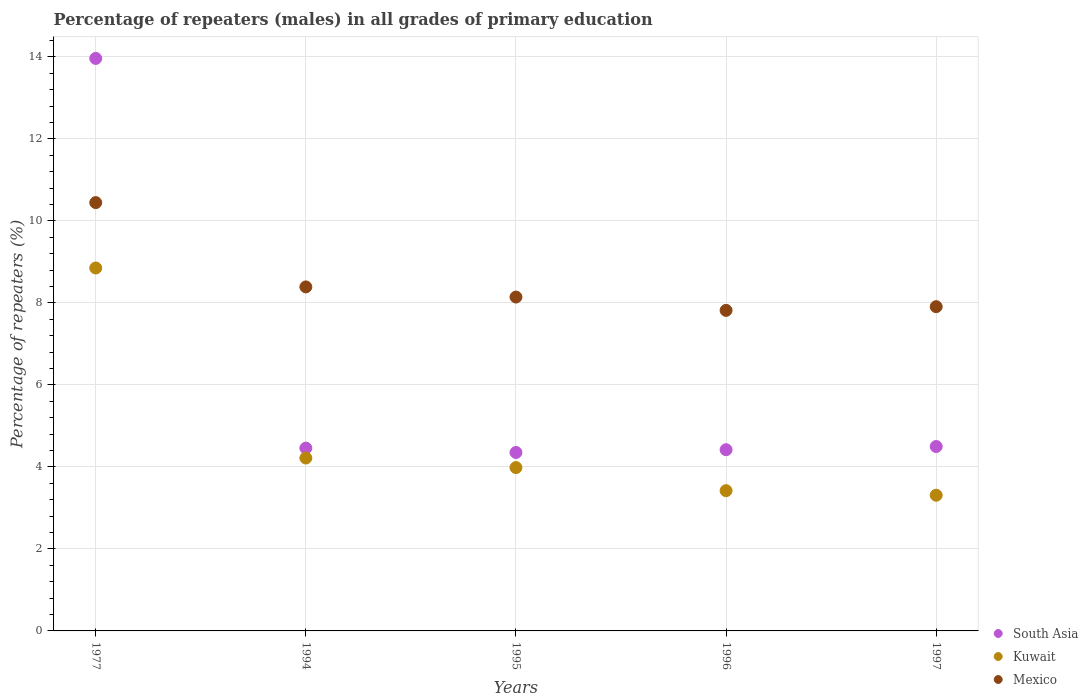What is the percentage of repeaters (males) in Kuwait in 1977?
Provide a succinct answer. 8.85. Across all years, what is the maximum percentage of repeaters (males) in South Asia?
Your answer should be compact. 13.96. Across all years, what is the minimum percentage of repeaters (males) in Mexico?
Keep it short and to the point. 7.82. In which year was the percentage of repeaters (males) in Kuwait maximum?
Provide a short and direct response. 1977. What is the total percentage of repeaters (males) in Mexico in the graph?
Ensure brevity in your answer.  42.71. What is the difference between the percentage of repeaters (males) in South Asia in 1996 and that in 1997?
Provide a short and direct response. -0.08. What is the difference between the percentage of repeaters (males) in South Asia in 1994 and the percentage of repeaters (males) in Kuwait in 1997?
Provide a short and direct response. 1.15. What is the average percentage of repeaters (males) in Mexico per year?
Your answer should be very brief. 8.54. In the year 1996, what is the difference between the percentage of repeaters (males) in Kuwait and percentage of repeaters (males) in South Asia?
Provide a short and direct response. -1. In how many years, is the percentage of repeaters (males) in Kuwait greater than 13.6 %?
Offer a very short reply. 0. What is the ratio of the percentage of repeaters (males) in Kuwait in 1996 to that in 1997?
Make the answer very short. 1.03. Is the difference between the percentage of repeaters (males) in Kuwait in 1977 and 1994 greater than the difference between the percentage of repeaters (males) in South Asia in 1977 and 1994?
Keep it short and to the point. No. What is the difference between the highest and the second highest percentage of repeaters (males) in Kuwait?
Provide a short and direct response. 4.63. What is the difference between the highest and the lowest percentage of repeaters (males) in South Asia?
Your answer should be very brief. 9.61. Is the sum of the percentage of repeaters (males) in South Asia in 1995 and 1997 greater than the maximum percentage of repeaters (males) in Mexico across all years?
Give a very brief answer. No. Does the percentage of repeaters (males) in South Asia monotonically increase over the years?
Keep it short and to the point. No. Is the percentage of repeaters (males) in South Asia strictly less than the percentage of repeaters (males) in Kuwait over the years?
Provide a succinct answer. No. How many years are there in the graph?
Ensure brevity in your answer.  5. Does the graph contain grids?
Provide a short and direct response. Yes. How are the legend labels stacked?
Provide a succinct answer. Vertical. What is the title of the graph?
Offer a very short reply. Percentage of repeaters (males) in all grades of primary education. Does "Vietnam" appear as one of the legend labels in the graph?
Provide a succinct answer. No. What is the label or title of the Y-axis?
Your answer should be compact. Percentage of repeaters (%). What is the Percentage of repeaters (%) of South Asia in 1977?
Offer a very short reply. 13.96. What is the Percentage of repeaters (%) of Kuwait in 1977?
Your answer should be very brief. 8.85. What is the Percentage of repeaters (%) of Mexico in 1977?
Your answer should be very brief. 10.45. What is the Percentage of repeaters (%) in South Asia in 1994?
Your answer should be compact. 4.46. What is the Percentage of repeaters (%) in Kuwait in 1994?
Provide a short and direct response. 4.22. What is the Percentage of repeaters (%) of Mexico in 1994?
Make the answer very short. 8.39. What is the Percentage of repeaters (%) in South Asia in 1995?
Provide a short and direct response. 4.35. What is the Percentage of repeaters (%) of Kuwait in 1995?
Your answer should be compact. 3.98. What is the Percentage of repeaters (%) in Mexico in 1995?
Your answer should be very brief. 8.14. What is the Percentage of repeaters (%) in South Asia in 1996?
Provide a succinct answer. 4.42. What is the Percentage of repeaters (%) of Kuwait in 1996?
Provide a short and direct response. 3.42. What is the Percentage of repeaters (%) of Mexico in 1996?
Provide a short and direct response. 7.82. What is the Percentage of repeaters (%) of South Asia in 1997?
Ensure brevity in your answer.  4.5. What is the Percentage of repeaters (%) of Kuwait in 1997?
Provide a short and direct response. 3.31. What is the Percentage of repeaters (%) of Mexico in 1997?
Offer a terse response. 7.91. Across all years, what is the maximum Percentage of repeaters (%) of South Asia?
Provide a short and direct response. 13.96. Across all years, what is the maximum Percentage of repeaters (%) in Kuwait?
Offer a terse response. 8.85. Across all years, what is the maximum Percentage of repeaters (%) of Mexico?
Offer a very short reply. 10.45. Across all years, what is the minimum Percentage of repeaters (%) in South Asia?
Give a very brief answer. 4.35. Across all years, what is the minimum Percentage of repeaters (%) in Kuwait?
Make the answer very short. 3.31. Across all years, what is the minimum Percentage of repeaters (%) in Mexico?
Make the answer very short. 7.82. What is the total Percentage of repeaters (%) in South Asia in the graph?
Make the answer very short. 31.69. What is the total Percentage of repeaters (%) of Kuwait in the graph?
Make the answer very short. 23.78. What is the total Percentage of repeaters (%) in Mexico in the graph?
Keep it short and to the point. 42.71. What is the difference between the Percentage of repeaters (%) in South Asia in 1977 and that in 1994?
Keep it short and to the point. 9.5. What is the difference between the Percentage of repeaters (%) in Kuwait in 1977 and that in 1994?
Ensure brevity in your answer.  4.63. What is the difference between the Percentage of repeaters (%) of Mexico in 1977 and that in 1994?
Provide a short and direct response. 2.06. What is the difference between the Percentage of repeaters (%) of South Asia in 1977 and that in 1995?
Your answer should be very brief. 9.61. What is the difference between the Percentage of repeaters (%) of Kuwait in 1977 and that in 1995?
Your response must be concise. 4.87. What is the difference between the Percentage of repeaters (%) of Mexico in 1977 and that in 1995?
Keep it short and to the point. 2.3. What is the difference between the Percentage of repeaters (%) of South Asia in 1977 and that in 1996?
Keep it short and to the point. 9.54. What is the difference between the Percentage of repeaters (%) of Kuwait in 1977 and that in 1996?
Offer a very short reply. 5.43. What is the difference between the Percentage of repeaters (%) in Mexico in 1977 and that in 1996?
Make the answer very short. 2.63. What is the difference between the Percentage of repeaters (%) in South Asia in 1977 and that in 1997?
Provide a short and direct response. 9.47. What is the difference between the Percentage of repeaters (%) of Kuwait in 1977 and that in 1997?
Your answer should be compact. 5.54. What is the difference between the Percentage of repeaters (%) in Mexico in 1977 and that in 1997?
Ensure brevity in your answer.  2.54. What is the difference between the Percentage of repeaters (%) in South Asia in 1994 and that in 1995?
Offer a terse response. 0.11. What is the difference between the Percentage of repeaters (%) in Kuwait in 1994 and that in 1995?
Offer a very short reply. 0.23. What is the difference between the Percentage of repeaters (%) in Mexico in 1994 and that in 1995?
Ensure brevity in your answer.  0.25. What is the difference between the Percentage of repeaters (%) of South Asia in 1994 and that in 1996?
Make the answer very short. 0.04. What is the difference between the Percentage of repeaters (%) in Kuwait in 1994 and that in 1996?
Your answer should be compact. 0.8. What is the difference between the Percentage of repeaters (%) in Mexico in 1994 and that in 1996?
Offer a very short reply. 0.57. What is the difference between the Percentage of repeaters (%) in South Asia in 1994 and that in 1997?
Ensure brevity in your answer.  -0.04. What is the difference between the Percentage of repeaters (%) in Kuwait in 1994 and that in 1997?
Ensure brevity in your answer.  0.91. What is the difference between the Percentage of repeaters (%) in Mexico in 1994 and that in 1997?
Make the answer very short. 0.48. What is the difference between the Percentage of repeaters (%) of South Asia in 1995 and that in 1996?
Make the answer very short. -0.07. What is the difference between the Percentage of repeaters (%) of Kuwait in 1995 and that in 1996?
Your answer should be compact. 0.56. What is the difference between the Percentage of repeaters (%) of Mexico in 1995 and that in 1996?
Your answer should be very brief. 0.33. What is the difference between the Percentage of repeaters (%) of South Asia in 1995 and that in 1997?
Provide a short and direct response. -0.14. What is the difference between the Percentage of repeaters (%) of Kuwait in 1995 and that in 1997?
Keep it short and to the point. 0.67. What is the difference between the Percentage of repeaters (%) of Mexico in 1995 and that in 1997?
Provide a short and direct response. 0.23. What is the difference between the Percentage of repeaters (%) in South Asia in 1996 and that in 1997?
Provide a short and direct response. -0.08. What is the difference between the Percentage of repeaters (%) of Kuwait in 1996 and that in 1997?
Provide a succinct answer. 0.11. What is the difference between the Percentage of repeaters (%) of Mexico in 1996 and that in 1997?
Provide a succinct answer. -0.09. What is the difference between the Percentage of repeaters (%) in South Asia in 1977 and the Percentage of repeaters (%) in Kuwait in 1994?
Your response must be concise. 9.75. What is the difference between the Percentage of repeaters (%) of South Asia in 1977 and the Percentage of repeaters (%) of Mexico in 1994?
Offer a terse response. 5.57. What is the difference between the Percentage of repeaters (%) in Kuwait in 1977 and the Percentage of repeaters (%) in Mexico in 1994?
Provide a short and direct response. 0.46. What is the difference between the Percentage of repeaters (%) in South Asia in 1977 and the Percentage of repeaters (%) in Kuwait in 1995?
Provide a succinct answer. 9.98. What is the difference between the Percentage of repeaters (%) in South Asia in 1977 and the Percentage of repeaters (%) in Mexico in 1995?
Offer a terse response. 5.82. What is the difference between the Percentage of repeaters (%) of Kuwait in 1977 and the Percentage of repeaters (%) of Mexico in 1995?
Offer a terse response. 0.71. What is the difference between the Percentage of repeaters (%) in South Asia in 1977 and the Percentage of repeaters (%) in Kuwait in 1996?
Your answer should be compact. 10.54. What is the difference between the Percentage of repeaters (%) in South Asia in 1977 and the Percentage of repeaters (%) in Mexico in 1996?
Provide a succinct answer. 6.15. What is the difference between the Percentage of repeaters (%) in Kuwait in 1977 and the Percentage of repeaters (%) in Mexico in 1996?
Your response must be concise. 1.03. What is the difference between the Percentage of repeaters (%) of South Asia in 1977 and the Percentage of repeaters (%) of Kuwait in 1997?
Provide a succinct answer. 10.65. What is the difference between the Percentage of repeaters (%) of South Asia in 1977 and the Percentage of repeaters (%) of Mexico in 1997?
Ensure brevity in your answer.  6.05. What is the difference between the Percentage of repeaters (%) in Kuwait in 1977 and the Percentage of repeaters (%) in Mexico in 1997?
Offer a very short reply. 0.94. What is the difference between the Percentage of repeaters (%) in South Asia in 1994 and the Percentage of repeaters (%) in Kuwait in 1995?
Keep it short and to the point. 0.48. What is the difference between the Percentage of repeaters (%) of South Asia in 1994 and the Percentage of repeaters (%) of Mexico in 1995?
Your response must be concise. -3.68. What is the difference between the Percentage of repeaters (%) of Kuwait in 1994 and the Percentage of repeaters (%) of Mexico in 1995?
Provide a short and direct response. -3.93. What is the difference between the Percentage of repeaters (%) of South Asia in 1994 and the Percentage of repeaters (%) of Kuwait in 1996?
Offer a very short reply. 1.04. What is the difference between the Percentage of repeaters (%) of South Asia in 1994 and the Percentage of repeaters (%) of Mexico in 1996?
Offer a very short reply. -3.36. What is the difference between the Percentage of repeaters (%) of Kuwait in 1994 and the Percentage of repeaters (%) of Mexico in 1996?
Your response must be concise. -3.6. What is the difference between the Percentage of repeaters (%) in South Asia in 1994 and the Percentage of repeaters (%) in Kuwait in 1997?
Your answer should be compact. 1.15. What is the difference between the Percentage of repeaters (%) in South Asia in 1994 and the Percentage of repeaters (%) in Mexico in 1997?
Offer a very short reply. -3.45. What is the difference between the Percentage of repeaters (%) of Kuwait in 1994 and the Percentage of repeaters (%) of Mexico in 1997?
Keep it short and to the point. -3.69. What is the difference between the Percentage of repeaters (%) of South Asia in 1995 and the Percentage of repeaters (%) of Kuwait in 1996?
Make the answer very short. 0.93. What is the difference between the Percentage of repeaters (%) of South Asia in 1995 and the Percentage of repeaters (%) of Mexico in 1996?
Offer a terse response. -3.47. What is the difference between the Percentage of repeaters (%) of Kuwait in 1995 and the Percentage of repeaters (%) of Mexico in 1996?
Offer a very short reply. -3.83. What is the difference between the Percentage of repeaters (%) of South Asia in 1995 and the Percentage of repeaters (%) of Kuwait in 1997?
Ensure brevity in your answer.  1.04. What is the difference between the Percentage of repeaters (%) of South Asia in 1995 and the Percentage of repeaters (%) of Mexico in 1997?
Your response must be concise. -3.56. What is the difference between the Percentage of repeaters (%) in Kuwait in 1995 and the Percentage of repeaters (%) in Mexico in 1997?
Your answer should be compact. -3.92. What is the difference between the Percentage of repeaters (%) in South Asia in 1996 and the Percentage of repeaters (%) in Kuwait in 1997?
Give a very brief answer. 1.11. What is the difference between the Percentage of repeaters (%) of South Asia in 1996 and the Percentage of repeaters (%) of Mexico in 1997?
Give a very brief answer. -3.49. What is the difference between the Percentage of repeaters (%) in Kuwait in 1996 and the Percentage of repeaters (%) in Mexico in 1997?
Provide a short and direct response. -4.49. What is the average Percentage of repeaters (%) of South Asia per year?
Provide a short and direct response. 6.34. What is the average Percentage of repeaters (%) in Kuwait per year?
Make the answer very short. 4.76. What is the average Percentage of repeaters (%) of Mexico per year?
Offer a very short reply. 8.54. In the year 1977, what is the difference between the Percentage of repeaters (%) of South Asia and Percentage of repeaters (%) of Kuwait?
Make the answer very short. 5.11. In the year 1977, what is the difference between the Percentage of repeaters (%) in South Asia and Percentage of repeaters (%) in Mexico?
Your response must be concise. 3.52. In the year 1977, what is the difference between the Percentage of repeaters (%) in Kuwait and Percentage of repeaters (%) in Mexico?
Offer a very short reply. -1.59. In the year 1994, what is the difference between the Percentage of repeaters (%) of South Asia and Percentage of repeaters (%) of Kuwait?
Ensure brevity in your answer.  0.24. In the year 1994, what is the difference between the Percentage of repeaters (%) of South Asia and Percentage of repeaters (%) of Mexico?
Give a very brief answer. -3.93. In the year 1994, what is the difference between the Percentage of repeaters (%) of Kuwait and Percentage of repeaters (%) of Mexico?
Provide a succinct answer. -4.17. In the year 1995, what is the difference between the Percentage of repeaters (%) of South Asia and Percentage of repeaters (%) of Kuwait?
Keep it short and to the point. 0.37. In the year 1995, what is the difference between the Percentage of repeaters (%) in South Asia and Percentage of repeaters (%) in Mexico?
Your answer should be compact. -3.79. In the year 1995, what is the difference between the Percentage of repeaters (%) in Kuwait and Percentage of repeaters (%) in Mexico?
Your answer should be very brief. -4.16. In the year 1996, what is the difference between the Percentage of repeaters (%) in South Asia and Percentage of repeaters (%) in Kuwait?
Give a very brief answer. 1. In the year 1996, what is the difference between the Percentage of repeaters (%) of South Asia and Percentage of repeaters (%) of Mexico?
Provide a succinct answer. -3.4. In the year 1996, what is the difference between the Percentage of repeaters (%) in Kuwait and Percentage of repeaters (%) in Mexico?
Provide a short and direct response. -4.4. In the year 1997, what is the difference between the Percentage of repeaters (%) of South Asia and Percentage of repeaters (%) of Kuwait?
Provide a succinct answer. 1.19. In the year 1997, what is the difference between the Percentage of repeaters (%) in South Asia and Percentage of repeaters (%) in Mexico?
Give a very brief answer. -3.41. In the year 1997, what is the difference between the Percentage of repeaters (%) in Kuwait and Percentage of repeaters (%) in Mexico?
Ensure brevity in your answer.  -4.6. What is the ratio of the Percentage of repeaters (%) in South Asia in 1977 to that in 1994?
Offer a very short reply. 3.13. What is the ratio of the Percentage of repeaters (%) of Kuwait in 1977 to that in 1994?
Ensure brevity in your answer.  2.1. What is the ratio of the Percentage of repeaters (%) in Mexico in 1977 to that in 1994?
Provide a succinct answer. 1.25. What is the ratio of the Percentage of repeaters (%) in South Asia in 1977 to that in 1995?
Your answer should be compact. 3.21. What is the ratio of the Percentage of repeaters (%) in Kuwait in 1977 to that in 1995?
Provide a succinct answer. 2.22. What is the ratio of the Percentage of repeaters (%) in Mexico in 1977 to that in 1995?
Your response must be concise. 1.28. What is the ratio of the Percentage of repeaters (%) in South Asia in 1977 to that in 1996?
Give a very brief answer. 3.16. What is the ratio of the Percentage of repeaters (%) in Kuwait in 1977 to that in 1996?
Provide a succinct answer. 2.59. What is the ratio of the Percentage of repeaters (%) of Mexico in 1977 to that in 1996?
Ensure brevity in your answer.  1.34. What is the ratio of the Percentage of repeaters (%) in South Asia in 1977 to that in 1997?
Make the answer very short. 3.1. What is the ratio of the Percentage of repeaters (%) of Kuwait in 1977 to that in 1997?
Your answer should be very brief. 2.67. What is the ratio of the Percentage of repeaters (%) of Mexico in 1977 to that in 1997?
Give a very brief answer. 1.32. What is the ratio of the Percentage of repeaters (%) of South Asia in 1994 to that in 1995?
Offer a very short reply. 1.02. What is the ratio of the Percentage of repeaters (%) in Kuwait in 1994 to that in 1995?
Make the answer very short. 1.06. What is the ratio of the Percentage of repeaters (%) in Mexico in 1994 to that in 1995?
Keep it short and to the point. 1.03. What is the ratio of the Percentage of repeaters (%) of South Asia in 1994 to that in 1996?
Your response must be concise. 1.01. What is the ratio of the Percentage of repeaters (%) of Kuwait in 1994 to that in 1996?
Give a very brief answer. 1.23. What is the ratio of the Percentage of repeaters (%) in Mexico in 1994 to that in 1996?
Make the answer very short. 1.07. What is the ratio of the Percentage of repeaters (%) in Kuwait in 1994 to that in 1997?
Give a very brief answer. 1.27. What is the ratio of the Percentage of repeaters (%) of Mexico in 1994 to that in 1997?
Offer a very short reply. 1.06. What is the ratio of the Percentage of repeaters (%) in Kuwait in 1995 to that in 1996?
Make the answer very short. 1.16. What is the ratio of the Percentage of repeaters (%) of Mexico in 1995 to that in 1996?
Your answer should be very brief. 1.04. What is the ratio of the Percentage of repeaters (%) of South Asia in 1995 to that in 1997?
Offer a very short reply. 0.97. What is the ratio of the Percentage of repeaters (%) of Kuwait in 1995 to that in 1997?
Your response must be concise. 1.2. What is the ratio of the Percentage of repeaters (%) of Mexico in 1995 to that in 1997?
Provide a short and direct response. 1.03. What is the ratio of the Percentage of repeaters (%) in South Asia in 1996 to that in 1997?
Provide a short and direct response. 0.98. What is the ratio of the Percentage of repeaters (%) of Kuwait in 1996 to that in 1997?
Offer a very short reply. 1.03. What is the ratio of the Percentage of repeaters (%) of Mexico in 1996 to that in 1997?
Offer a terse response. 0.99. What is the difference between the highest and the second highest Percentage of repeaters (%) of South Asia?
Your answer should be very brief. 9.47. What is the difference between the highest and the second highest Percentage of repeaters (%) of Kuwait?
Offer a terse response. 4.63. What is the difference between the highest and the second highest Percentage of repeaters (%) of Mexico?
Offer a terse response. 2.06. What is the difference between the highest and the lowest Percentage of repeaters (%) of South Asia?
Keep it short and to the point. 9.61. What is the difference between the highest and the lowest Percentage of repeaters (%) in Kuwait?
Ensure brevity in your answer.  5.54. What is the difference between the highest and the lowest Percentage of repeaters (%) of Mexico?
Offer a terse response. 2.63. 